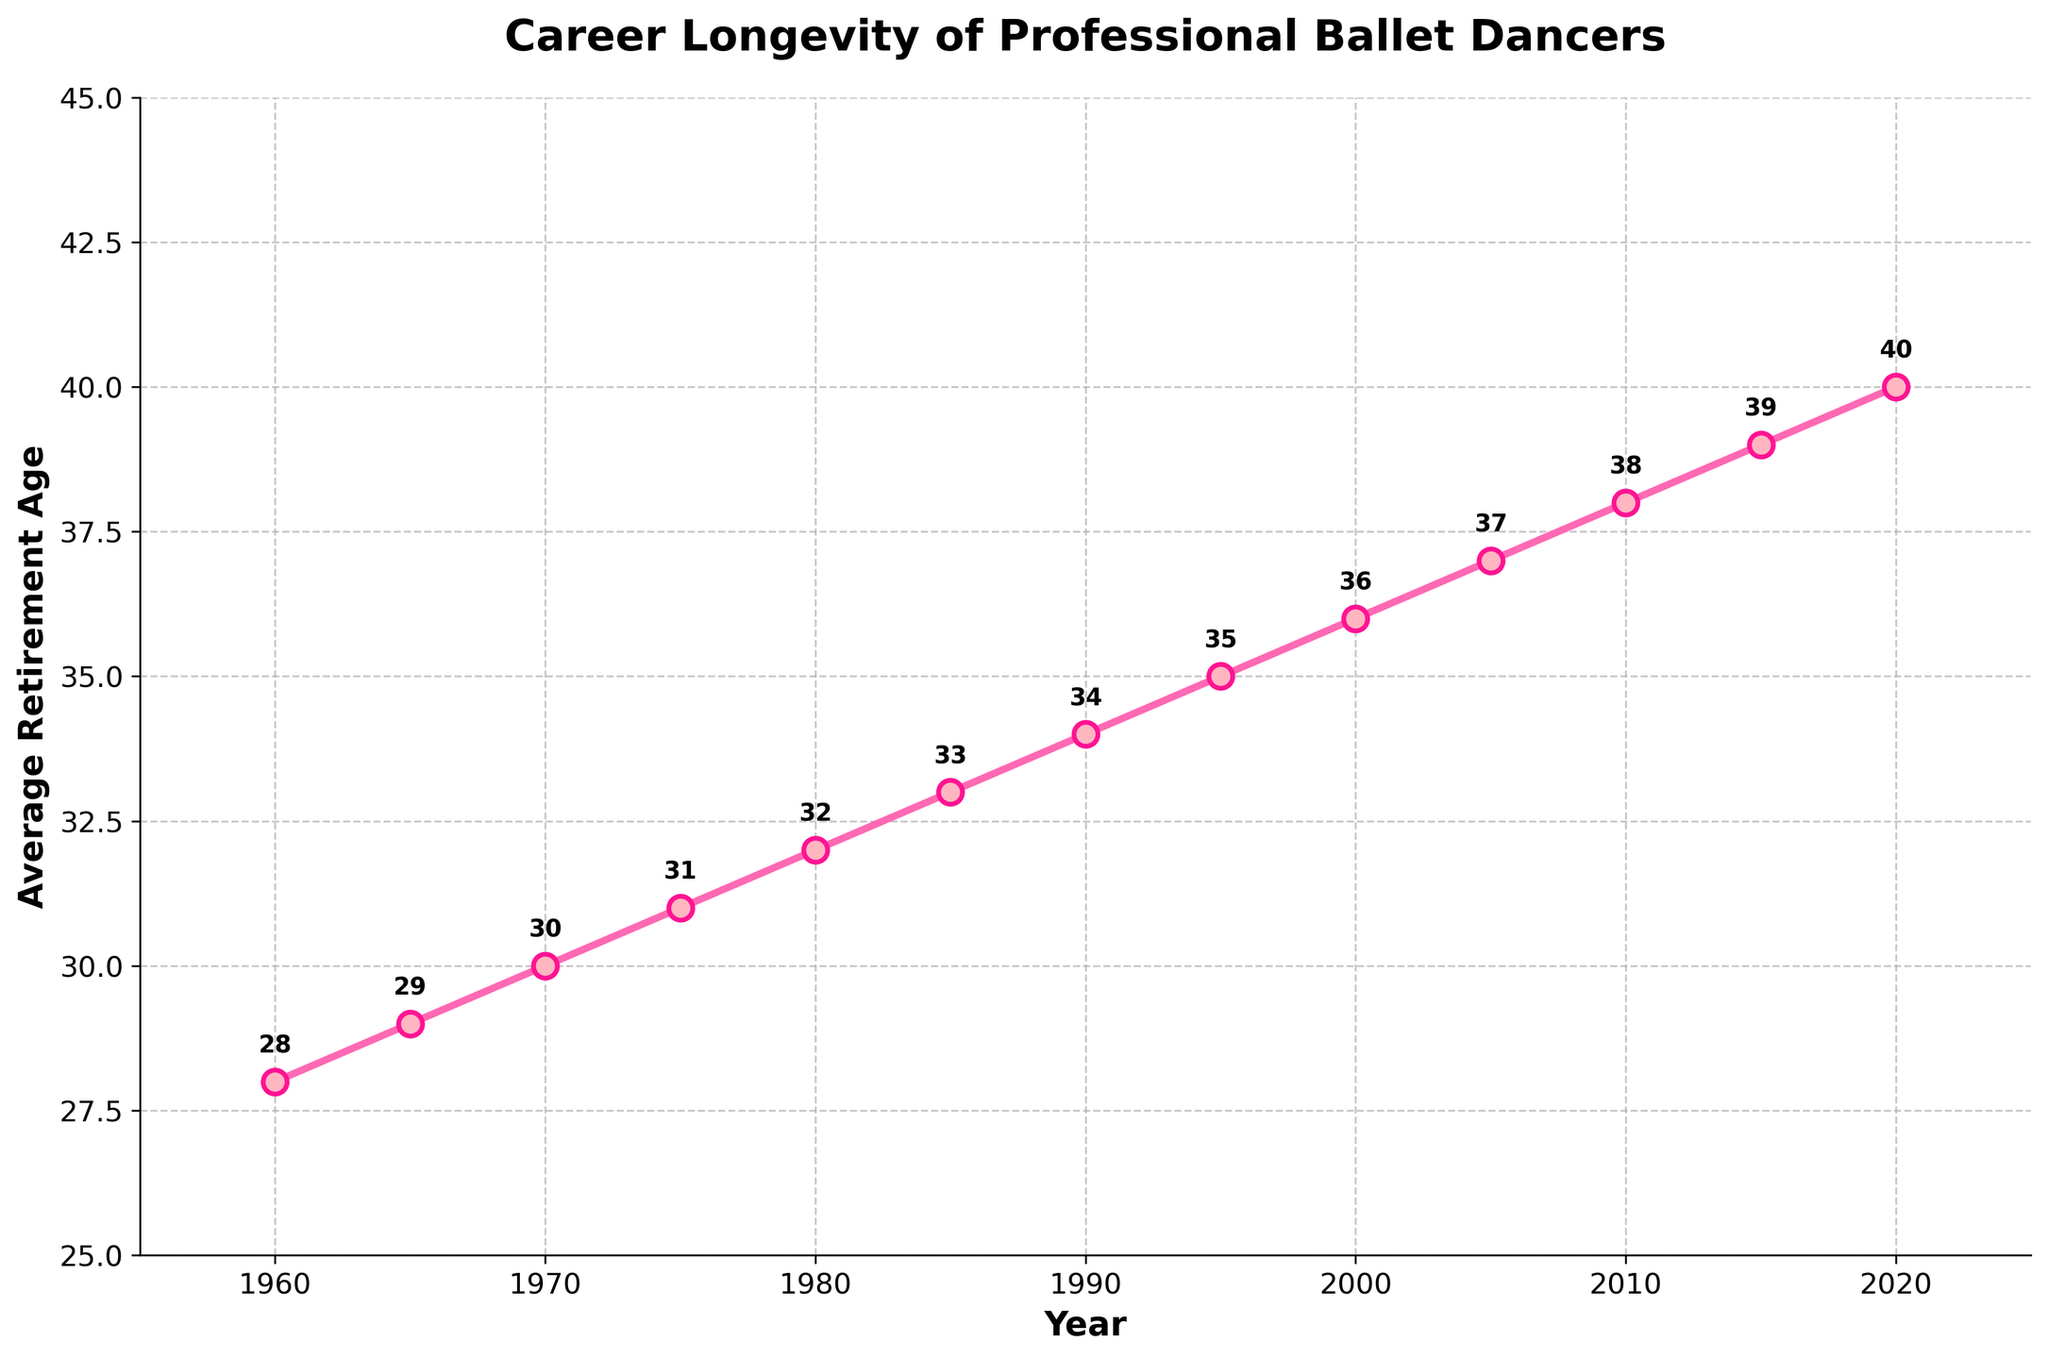What's the general trend in the average retirement age of professional ballet dancers from 1960 to 2020? The general trend can be observed by looking at the line connecting the data points from 1960 to 2020. The line shows a steady increase in the average retirement age over the years.
Answer: Steady increase What was the average retirement age of professional ballet dancers in 1980, and how does it compare to 2000? The average retirement age in 1980 is 32, and in 2000 it is 36. By comparing these two values, the average retirement age increased by 4 years over this period.
Answer: Increased by 4 years In what year did the average retirement age reach 40? Looking at the point where the average retirement age hits 40, it corresponds to the year 2020.
Answer: 2020 What is the difference in average retirement age between 1960 and 2020? The average retirement age in 1960 is 28, and in 2020 it is 40. The difference between these two values is 40 - 28 = 12 years.
Answer: 12 years Was there any period where the average retirement age did not increase? By observing the line chart, it appears the average retirement age consistently increased from 1960 to 2020 without any periods of stagnation or decrease.
Answer: No Which decade saw the highest increase in average retirement age? To find the decade with the highest increase, calculate the differences for each decade: 1960-1970 (2), 1970-1980 (2), 1980-1990 (2), 1990-2000 (2), 2000-2010 (2), 2010-2020 (2). All decades saw an increase of 2 years.
Answer: All decades had equal increases By how many years did the average retirement age increase from 1975 to 1990? The average retirement age in 1975 is 31, and in 1990 it is 34. The increase is 34 - 31 = 3 years.
Answer: 3 years What is the average of the average retirement ages for the years 1960, 1980, 2000, and 2020? First, sum the values for these years: 28 (1960) + 32 (1980) + 36 (2000) + 40 (2020) = 136. Then divide by the number of years, which is 4. So, 136 / 4 = 34.
Answer: 34 How does the average retirement age in 1965 compare to that in 2015? The average retirement age in 1965 is 29, and in 2015 it is 39. Comparing these, the 2015 average is 10 years higher than in 1965.
Answer: 10 years higher When does the greatest visual change in the slope of the line occur? The slope of the line appears relatively consistent, so no single point shows a drastic visual change. The overall trend shows a steady increase without abrupt changes.
Answer: No drastic visual change 